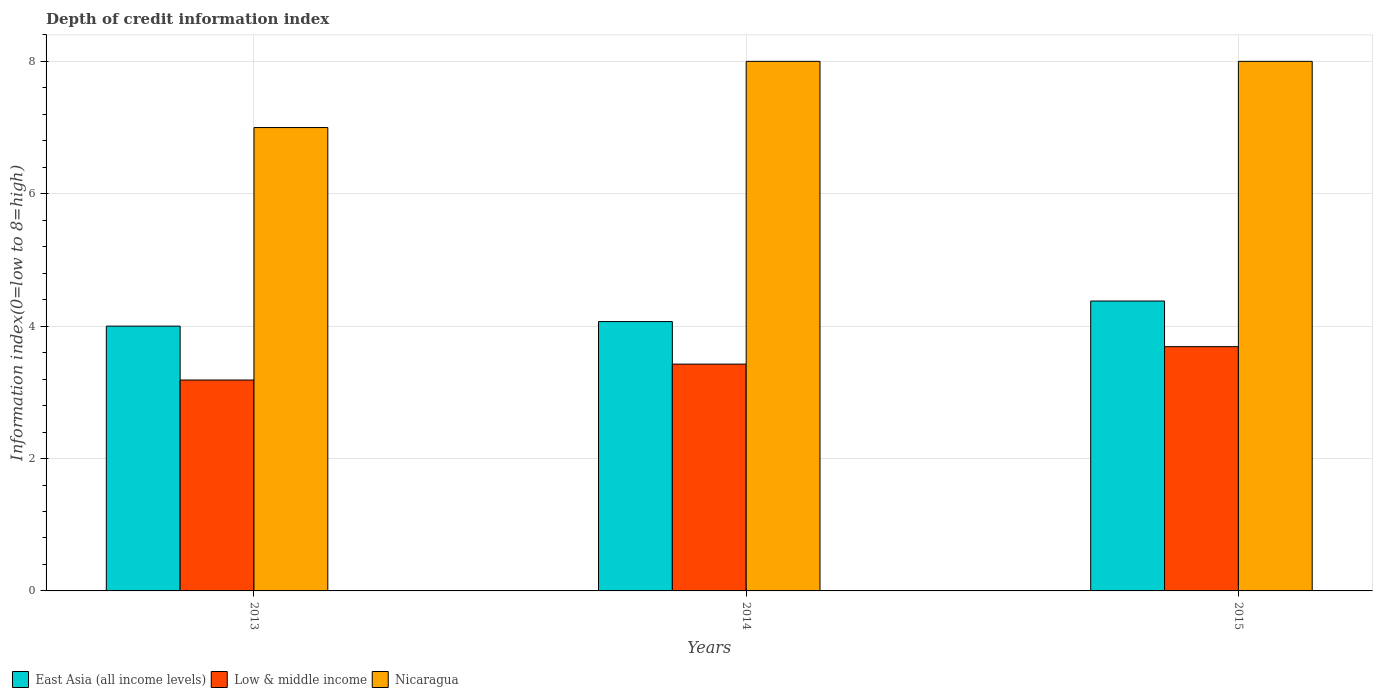How many different coloured bars are there?
Provide a short and direct response. 3. How many groups of bars are there?
Your response must be concise. 3. Are the number of bars on each tick of the X-axis equal?
Make the answer very short. Yes. In how many cases, is the number of bars for a given year not equal to the number of legend labels?
Your answer should be compact. 0. What is the information index in Low & middle income in 2014?
Your answer should be very brief. 3.43. Across all years, what is the maximum information index in East Asia (all income levels)?
Your answer should be compact. 4.38. Across all years, what is the minimum information index in Nicaragua?
Ensure brevity in your answer.  7. In which year was the information index in Low & middle income maximum?
Give a very brief answer. 2015. What is the total information index in Nicaragua in the graph?
Your answer should be very brief. 23. What is the difference between the information index in East Asia (all income levels) in 2014 and that in 2015?
Provide a short and direct response. -0.31. What is the difference between the information index in East Asia (all income levels) in 2014 and the information index in Low & middle income in 2013?
Provide a succinct answer. 0.88. What is the average information index in Nicaragua per year?
Offer a terse response. 7.67. In the year 2015, what is the difference between the information index in East Asia (all income levels) and information index in Nicaragua?
Your answer should be compact. -3.62. What is the ratio of the information index in Low & middle income in 2013 to that in 2014?
Provide a succinct answer. 0.93. Is the difference between the information index in East Asia (all income levels) in 2013 and 2014 greater than the difference between the information index in Nicaragua in 2013 and 2014?
Offer a terse response. Yes. What is the difference between the highest and the second highest information index in East Asia (all income levels)?
Provide a succinct answer. 0.31. What is the difference between the highest and the lowest information index in Low & middle income?
Offer a very short reply. 0.5. What does the 1st bar from the left in 2014 represents?
Your answer should be very brief. East Asia (all income levels). What does the 2nd bar from the right in 2014 represents?
Keep it short and to the point. Low & middle income. Is it the case that in every year, the sum of the information index in Nicaragua and information index in Low & middle income is greater than the information index in East Asia (all income levels)?
Provide a succinct answer. Yes. Are all the bars in the graph horizontal?
Your response must be concise. No. What is the difference between two consecutive major ticks on the Y-axis?
Offer a very short reply. 2. Are the values on the major ticks of Y-axis written in scientific E-notation?
Your answer should be very brief. No. Does the graph contain grids?
Offer a terse response. Yes. Where does the legend appear in the graph?
Give a very brief answer. Bottom left. How many legend labels are there?
Offer a terse response. 3. How are the legend labels stacked?
Your answer should be very brief. Horizontal. What is the title of the graph?
Give a very brief answer. Depth of credit information index. What is the label or title of the Y-axis?
Offer a terse response. Information index(0=low to 8=high). What is the Information index(0=low to 8=high) in East Asia (all income levels) in 2013?
Your answer should be compact. 4. What is the Information index(0=low to 8=high) in Low & middle income in 2013?
Offer a terse response. 3.19. What is the Information index(0=low to 8=high) of East Asia (all income levels) in 2014?
Offer a very short reply. 4.07. What is the Information index(0=low to 8=high) in Low & middle income in 2014?
Make the answer very short. 3.43. What is the Information index(0=low to 8=high) of East Asia (all income levels) in 2015?
Give a very brief answer. 4.38. What is the Information index(0=low to 8=high) in Low & middle income in 2015?
Your answer should be very brief. 3.69. Across all years, what is the maximum Information index(0=low to 8=high) of East Asia (all income levels)?
Ensure brevity in your answer.  4.38. Across all years, what is the maximum Information index(0=low to 8=high) of Low & middle income?
Make the answer very short. 3.69. Across all years, what is the maximum Information index(0=low to 8=high) in Nicaragua?
Your response must be concise. 8. Across all years, what is the minimum Information index(0=low to 8=high) of Low & middle income?
Provide a succinct answer. 3.19. Across all years, what is the minimum Information index(0=low to 8=high) of Nicaragua?
Keep it short and to the point. 7. What is the total Information index(0=low to 8=high) of East Asia (all income levels) in the graph?
Offer a very short reply. 12.45. What is the total Information index(0=low to 8=high) of Low & middle income in the graph?
Your response must be concise. 10.3. What is the difference between the Information index(0=low to 8=high) of East Asia (all income levels) in 2013 and that in 2014?
Make the answer very short. -0.07. What is the difference between the Information index(0=low to 8=high) in Low & middle income in 2013 and that in 2014?
Ensure brevity in your answer.  -0.24. What is the difference between the Information index(0=low to 8=high) of Nicaragua in 2013 and that in 2014?
Your response must be concise. -1. What is the difference between the Information index(0=low to 8=high) of East Asia (all income levels) in 2013 and that in 2015?
Ensure brevity in your answer.  -0.38. What is the difference between the Information index(0=low to 8=high) in Low & middle income in 2013 and that in 2015?
Provide a short and direct response. -0.5. What is the difference between the Information index(0=low to 8=high) of Nicaragua in 2013 and that in 2015?
Ensure brevity in your answer.  -1. What is the difference between the Information index(0=low to 8=high) of East Asia (all income levels) in 2014 and that in 2015?
Your answer should be very brief. -0.31. What is the difference between the Information index(0=low to 8=high) in Low & middle income in 2014 and that in 2015?
Provide a short and direct response. -0.26. What is the difference between the Information index(0=low to 8=high) in East Asia (all income levels) in 2013 and the Information index(0=low to 8=high) in Low & middle income in 2014?
Make the answer very short. 0.57. What is the difference between the Information index(0=low to 8=high) of East Asia (all income levels) in 2013 and the Information index(0=low to 8=high) of Nicaragua in 2014?
Your answer should be compact. -4. What is the difference between the Information index(0=low to 8=high) of Low & middle income in 2013 and the Information index(0=low to 8=high) of Nicaragua in 2014?
Your response must be concise. -4.81. What is the difference between the Information index(0=low to 8=high) of East Asia (all income levels) in 2013 and the Information index(0=low to 8=high) of Low & middle income in 2015?
Offer a terse response. 0.31. What is the difference between the Information index(0=low to 8=high) of East Asia (all income levels) in 2013 and the Information index(0=low to 8=high) of Nicaragua in 2015?
Give a very brief answer. -4. What is the difference between the Information index(0=low to 8=high) of Low & middle income in 2013 and the Information index(0=low to 8=high) of Nicaragua in 2015?
Offer a very short reply. -4.81. What is the difference between the Information index(0=low to 8=high) of East Asia (all income levels) in 2014 and the Information index(0=low to 8=high) of Low & middle income in 2015?
Provide a succinct answer. 0.38. What is the difference between the Information index(0=low to 8=high) in East Asia (all income levels) in 2014 and the Information index(0=low to 8=high) in Nicaragua in 2015?
Your answer should be very brief. -3.93. What is the difference between the Information index(0=low to 8=high) of Low & middle income in 2014 and the Information index(0=low to 8=high) of Nicaragua in 2015?
Offer a terse response. -4.57. What is the average Information index(0=low to 8=high) in East Asia (all income levels) per year?
Your response must be concise. 4.15. What is the average Information index(0=low to 8=high) in Low & middle income per year?
Offer a very short reply. 3.43. What is the average Information index(0=low to 8=high) in Nicaragua per year?
Keep it short and to the point. 7.67. In the year 2013, what is the difference between the Information index(0=low to 8=high) in East Asia (all income levels) and Information index(0=low to 8=high) in Low & middle income?
Your answer should be compact. 0.81. In the year 2013, what is the difference between the Information index(0=low to 8=high) of Low & middle income and Information index(0=low to 8=high) of Nicaragua?
Make the answer very short. -3.81. In the year 2014, what is the difference between the Information index(0=low to 8=high) of East Asia (all income levels) and Information index(0=low to 8=high) of Low & middle income?
Your answer should be very brief. 0.64. In the year 2014, what is the difference between the Information index(0=low to 8=high) of East Asia (all income levels) and Information index(0=low to 8=high) of Nicaragua?
Your answer should be very brief. -3.93. In the year 2014, what is the difference between the Information index(0=low to 8=high) in Low & middle income and Information index(0=low to 8=high) in Nicaragua?
Offer a terse response. -4.57. In the year 2015, what is the difference between the Information index(0=low to 8=high) of East Asia (all income levels) and Information index(0=low to 8=high) of Low & middle income?
Ensure brevity in your answer.  0.69. In the year 2015, what is the difference between the Information index(0=low to 8=high) of East Asia (all income levels) and Information index(0=low to 8=high) of Nicaragua?
Ensure brevity in your answer.  -3.62. In the year 2015, what is the difference between the Information index(0=low to 8=high) in Low & middle income and Information index(0=low to 8=high) in Nicaragua?
Give a very brief answer. -4.31. What is the ratio of the Information index(0=low to 8=high) in East Asia (all income levels) in 2013 to that in 2014?
Offer a terse response. 0.98. What is the ratio of the Information index(0=low to 8=high) of Low & middle income in 2013 to that in 2014?
Give a very brief answer. 0.93. What is the ratio of the Information index(0=low to 8=high) of East Asia (all income levels) in 2013 to that in 2015?
Offer a very short reply. 0.91. What is the ratio of the Information index(0=low to 8=high) in Low & middle income in 2013 to that in 2015?
Provide a succinct answer. 0.86. What is the ratio of the Information index(0=low to 8=high) of East Asia (all income levels) in 2014 to that in 2015?
Give a very brief answer. 0.93. What is the difference between the highest and the second highest Information index(0=low to 8=high) of East Asia (all income levels)?
Provide a short and direct response. 0.31. What is the difference between the highest and the second highest Information index(0=low to 8=high) in Low & middle income?
Provide a succinct answer. 0.26. What is the difference between the highest and the lowest Information index(0=low to 8=high) in East Asia (all income levels)?
Keep it short and to the point. 0.38. What is the difference between the highest and the lowest Information index(0=low to 8=high) in Low & middle income?
Your answer should be very brief. 0.5. 